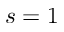<formula> <loc_0><loc_0><loc_500><loc_500>s = 1</formula> 